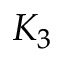Convert formula to latex. <formula><loc_0><loc_0><loc_500><loc_500>K _ { 3 }</formula> 